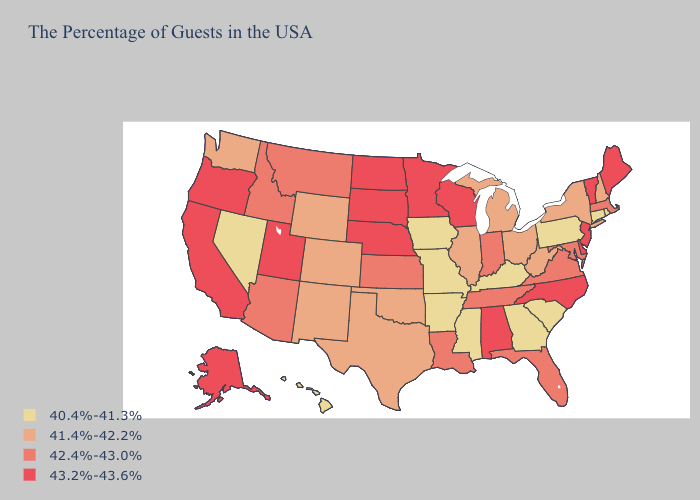Does Michigan have a lower value than Georgia?
Be succinct. No. What is the highest value in the Northeast ?
Answer briefly. 43.2%-43.6%. Name the states that have a value in the range 42.4%-43.0%?
Be succinct. Massachusetts, Maryland, Virginia, Florida, Indiana, Tennessee, Louisiana, Kansas, Montana, Arizona, Idaho. Name the states that have a value in the range 40.4%-41.3%?
Concise answer only. Rhode Island, Connecticut, Pennsylvania, South Carolina, Georgia, Kentucky, Mississippi, Missouri, Arkansas, Iowa, Nevada, Hawaii. Is the legend a continuous bar?
Short answer required. No. What is the value of Texas?
Be succinct. 41.4%-42.2%. What is the highest value in the West ?
Concise answer only. 43.2%-43.6%. Is the legend a continuous bar?
Write a very short answer. No. What is the highest value in the USA?
Be succinct. 43.2%-43.6%. What is the lowest value in the USA?
Answer briefly. 40.4%-41.3%. What is the highest value in the USA?
Be succinct. 43.2%-43.6%. What is the value of North Dakota?
Write a very short answer. 43.2%-43.6%. Does the first symbol in the legend represent the smallest category?
Write a very short answer. Yes. Which states have the highest value in the USA?
Answer briefly. Maine, Vermont, New Jersey, Delaware, North Carolina, Alabama, Wisconsin, Minnesota, Nebraska, South Dakota, North Dakota, Utah, California, Oregon, Alaska. Does Georgia have the lowest value in the USA?
Keep it brief. Yes. 